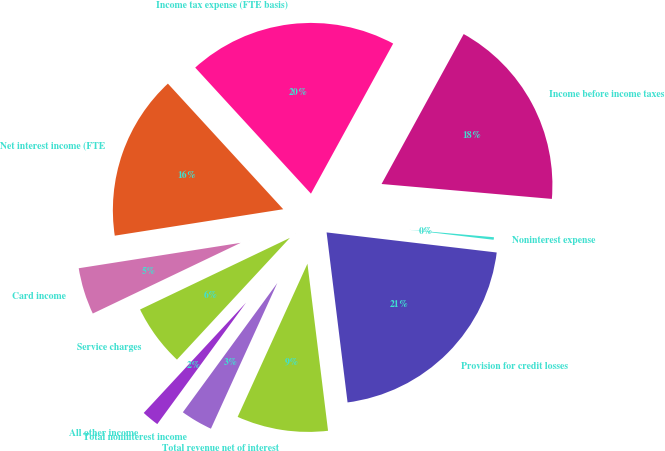Convert chart to OTSL. <chart><loc_0><loc_0><loc_500><loc_500><pie_chart><fcel>Net interest income (FTE<fcel>Card income<fcel>Service charges<fcel>All other income<fcel>Total noninterest income<fcel>Total revenue net of interest<fcel>Provision for credit losses<fcel>Noninterest expense<fcel>Income before income taxes<fcel>Income tax expense (FTE basis)<nl><fcel>15.66%<fcel>4.62%<fcel>6.0%<fcel>1.86%<fcel>3.24%<fcel>8.76%<fcel>21.18%<fcel>0.48%<fcel>18.42%<fcel>19.8%<nl></chart> 